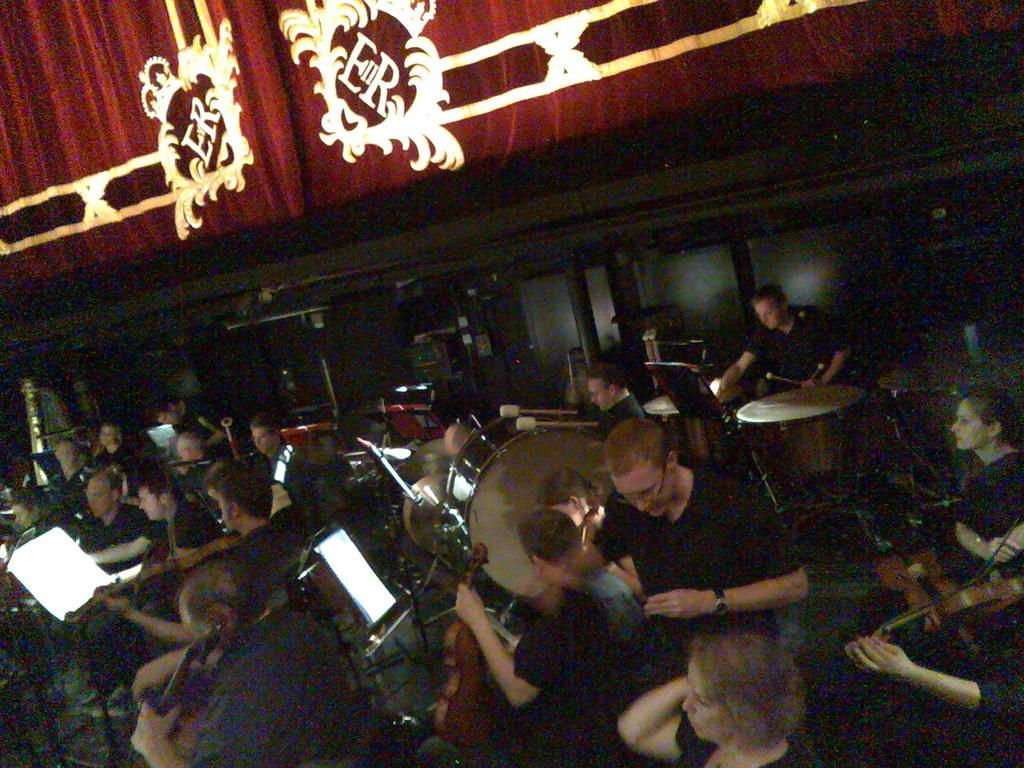What are the people in the image doing? The people in the image are playing musical instruments. Can you describe the person in front? The person in front is wearing a black color dress. What is the color of the background in the image? The background of the image is brown in color. What is the distance between the people and the nearest mountain in the image? There is no mountain visible in the image, so it is not possible to determine the distance between the people and a mountain. 